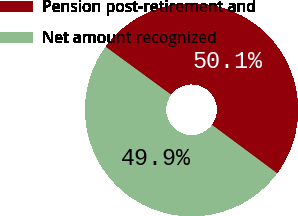Convert chart. <chart><loc_0><loc_0><loc_500><loc_500><pie_chart><fcel>Pension post-retirement and<fcel>Net amount recognized<nl><fcel>50.1%<fcel>49.9%<nl></chart> 